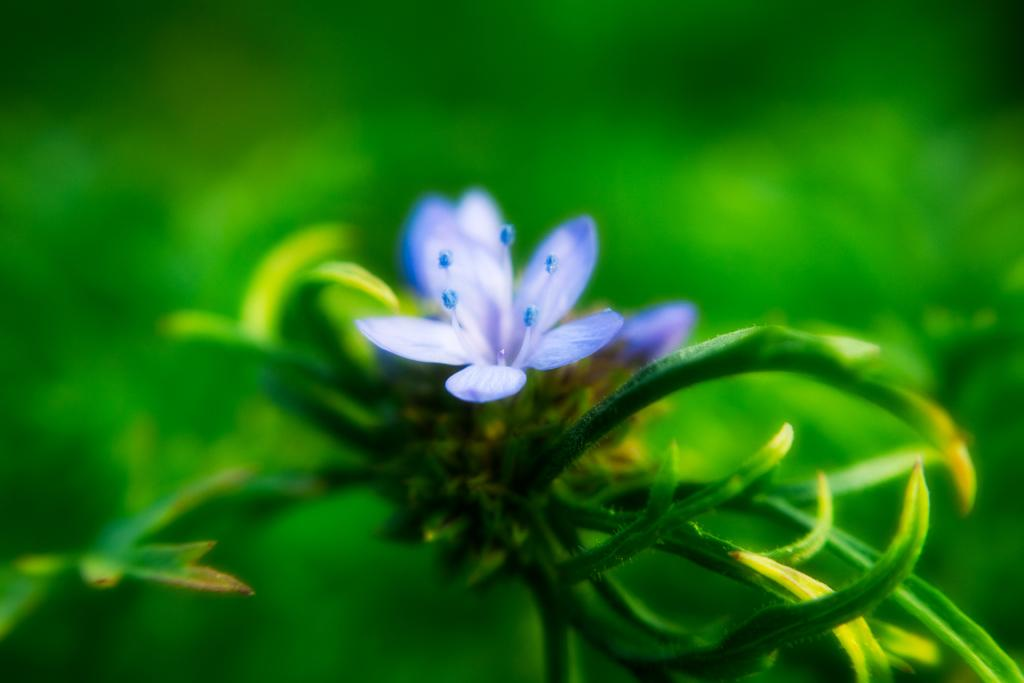What type of flower is in the image? There is a blue flower in the image. What other plant elements can be seen in the image? There are green leaves in the image. What color is the background of the image? The background of the image is green. How would you describe the quality of the image in the background? The image is blurry in the background. What type of division is taking place in the image? There is no division taking place in the image; it features a blue flower and green leaves. How many stalks of celery can be seen in the image? There is no celery present in the image. 